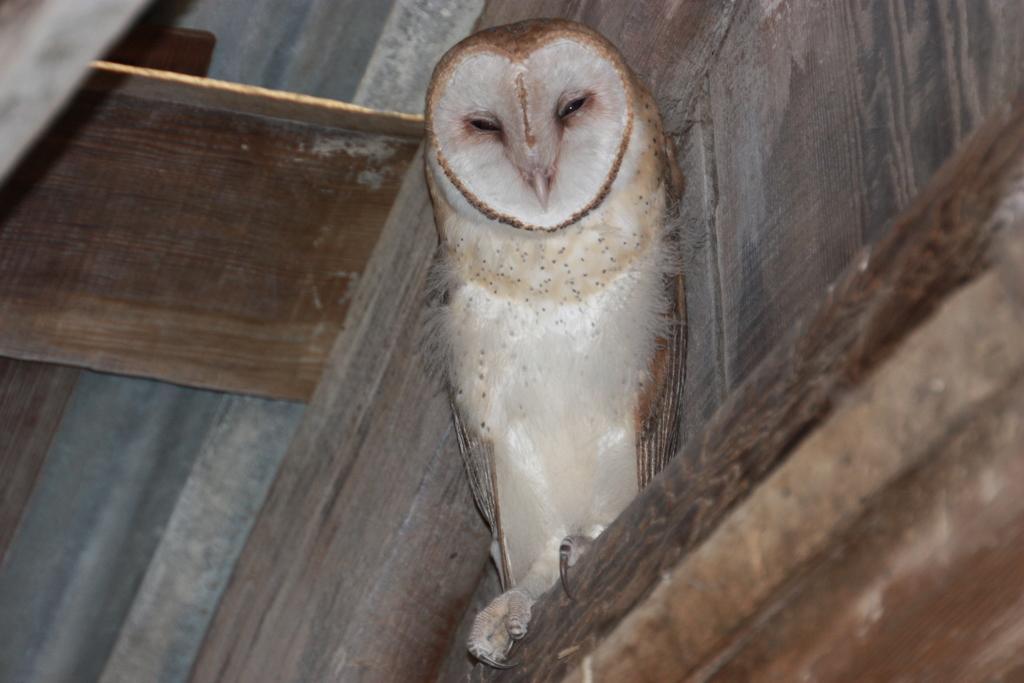In one or two sentences, can you explain what this image depicts? In this image we can see an owl and there are wooden planks. 